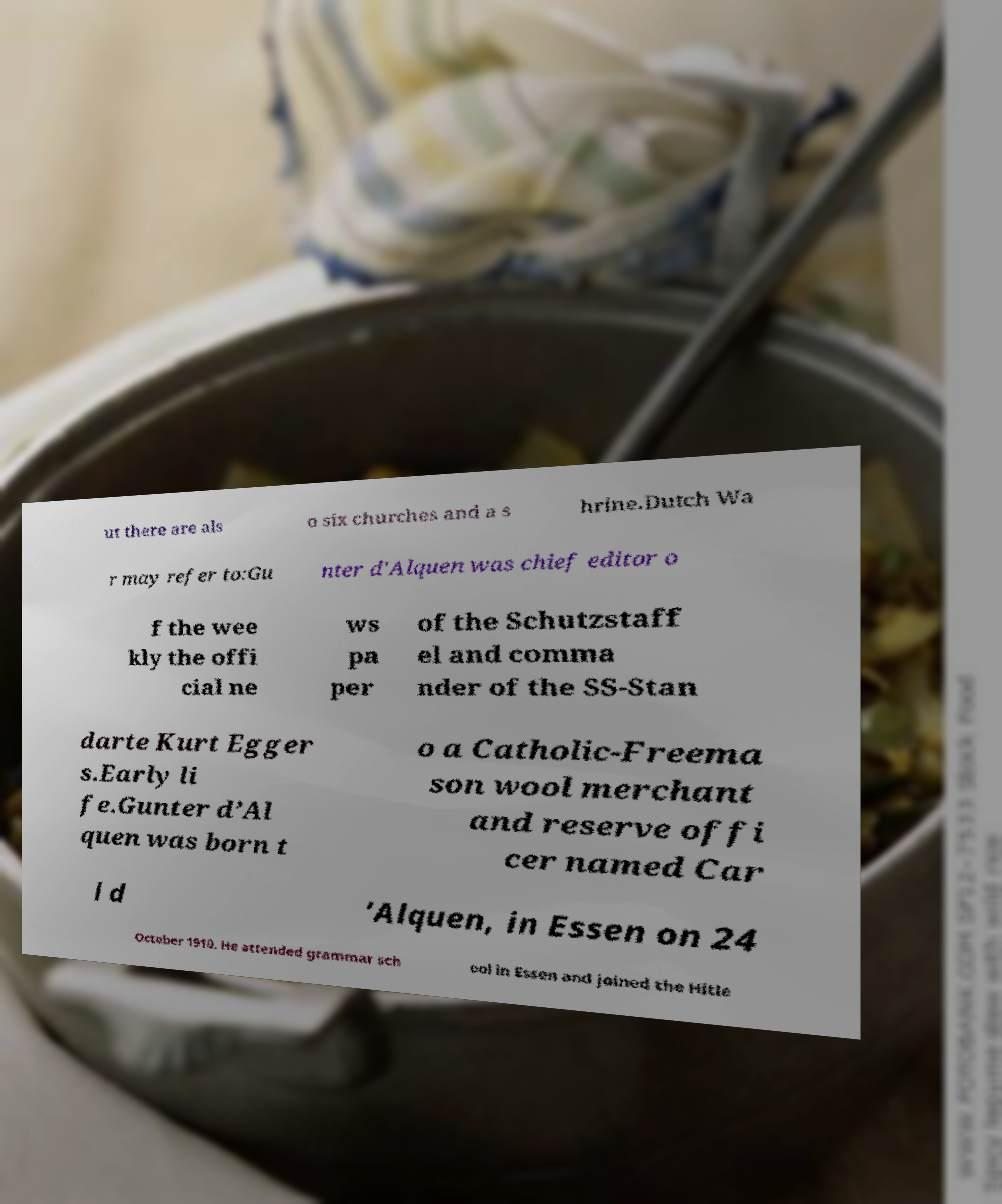Please read and relay the text visible in this image. What does it say? ut there are als o six churches and a s hrine.Dutch Wa r may refer to:Gu nter d'Alquen was chief editor o f the wee kly the offi cial ne ws pa per of the Schutzstaff el and comma nder of the SS-Stan darte Kurt Egger s.Early li fe.Gunter d’Al quen was born t o a Catholic-Freema son wool merchant and reserve offi cer named Car l d ’Alquen, in Essen on 24 October 1910. He attended grammar sch ool in Essen and joined the Hitle 